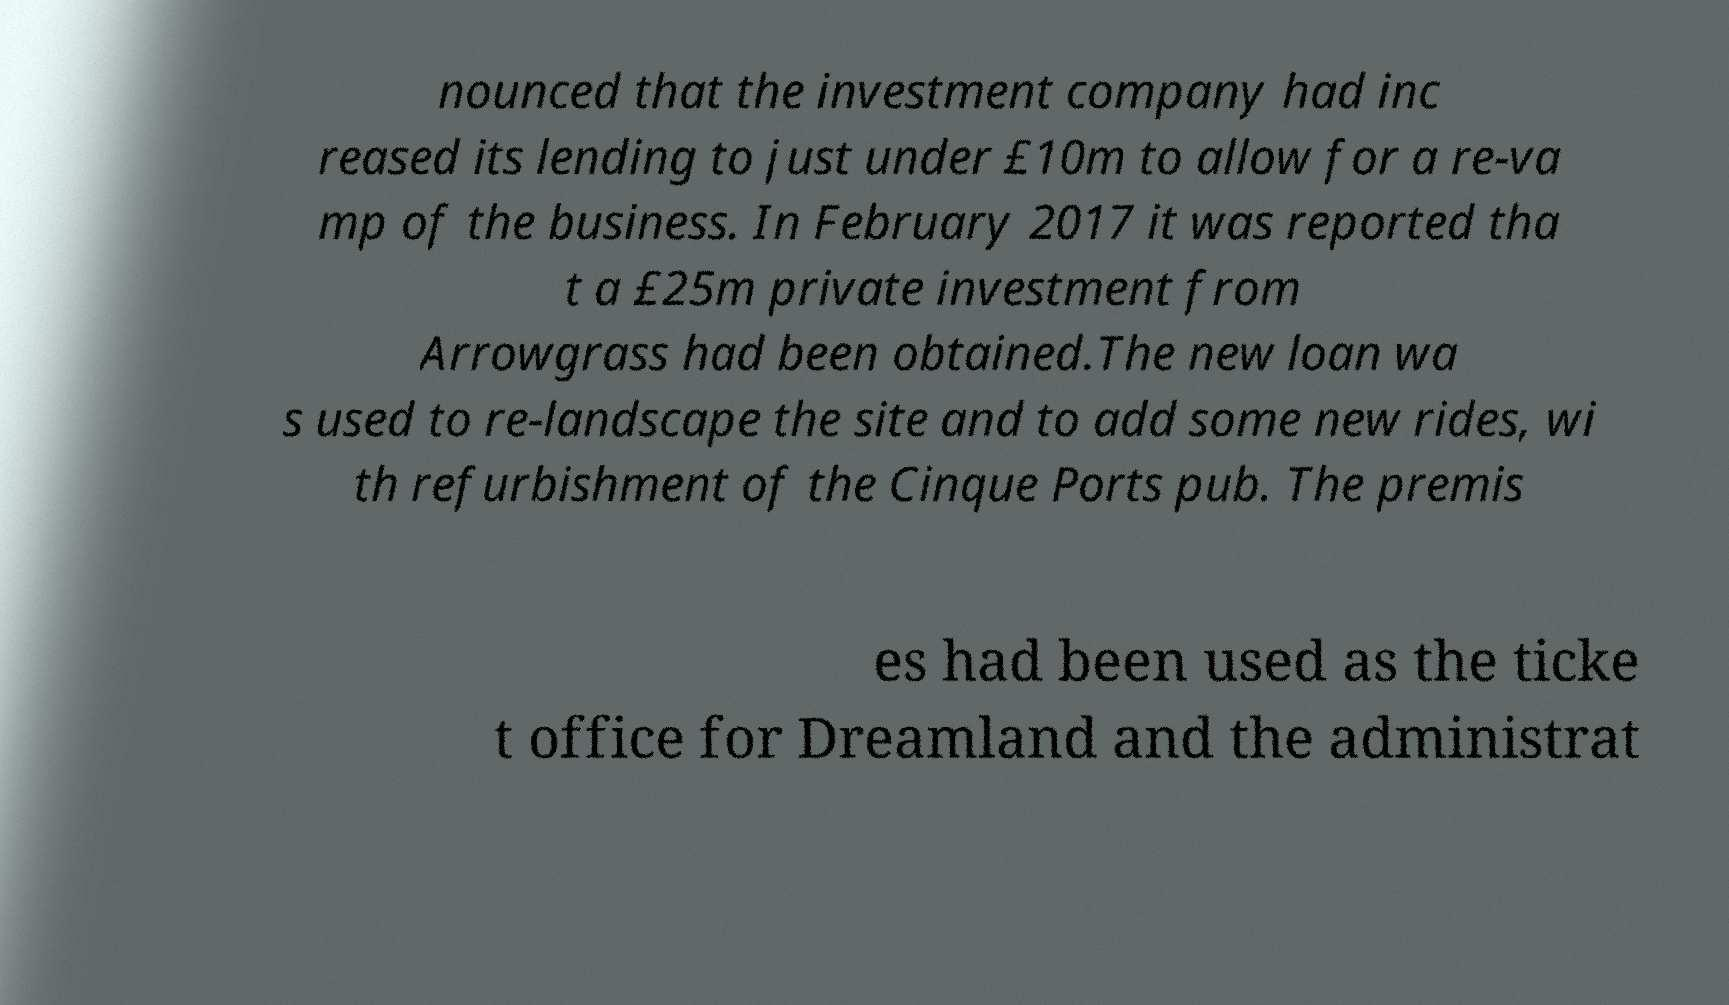Can you accurately transcribe the text from the provided image for me? nounced that the investment company had inc reased its lending to just under £10m to allow for a re-va mp of the business. In February 2017 it was reported tha t a £25m private investment from Arrowgrass had been obtained.The new loan wa s used to re-landscape the site and to add some new rides, wi th refurbishment of the Cinque Ports pub. The premis es had been used as the ticke t office for Dreamland and the administrat 